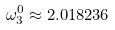<formula> <loc_0><loc_0><loc_500><loc_500>\omega _ { 3 } ^ { 0 } \approx 2 . 0 1 8 2 3 6</formula> 